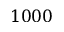Convert formula to latex. <formula><loc_0><loc_0><loc_500><loc_500>1 0 0 0</formula> 